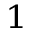<formula> <loc_0><loc_0><loc_500><loc_500>^ { 1 }</formula> 